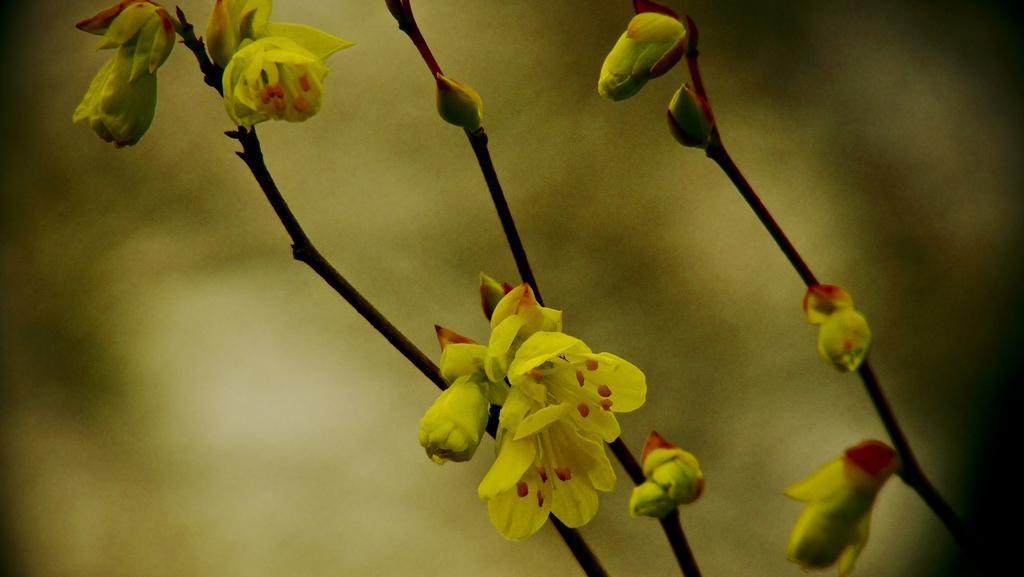In one or two sentences, can you explain what this image depicts? In the foreground of this picture we can see the flowers, buds and the stems. The background of the image is blurry. 